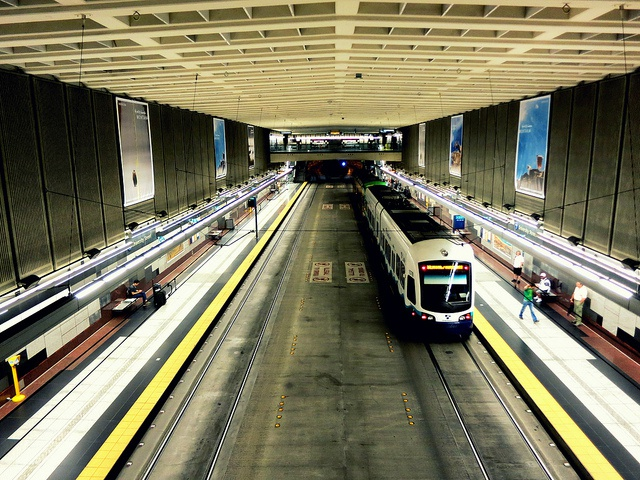Describe the objects in this image and their specific colors. I can see train in darkgreen, black, gray, ivory, and beige tones, train in darkgreen, black, ivory, tan, and gray tones, bench in darkgreen, black, maroon, and gray tones, people in darkgreen, ivory, olive, gray, and salmon tones, and people in darkgreen, green, gray, black, and blue tones in this image. 